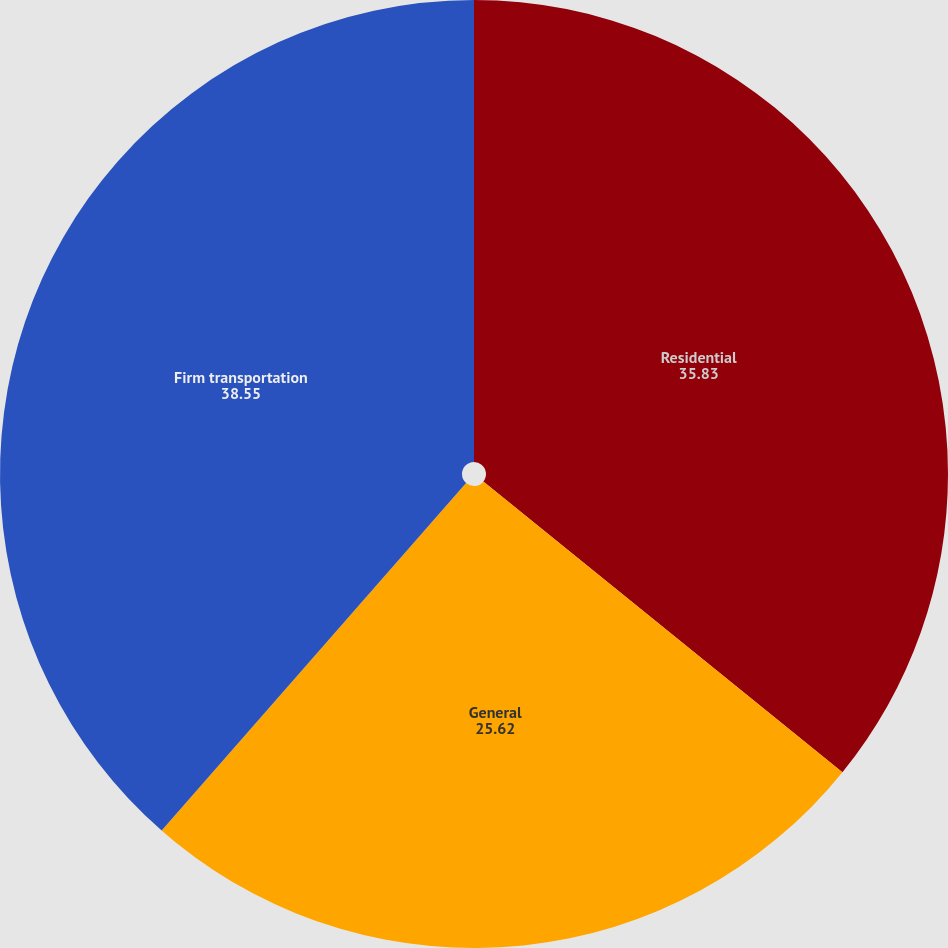<chart> <loc_0><loc_0><loc_500><loc_500><pie_chart><fcel>Residential<fcel>General<fcel>Firm transportation<nl><fcel>35.83%<fcel>25.62%<fcel>38.55%<nl></chart> 